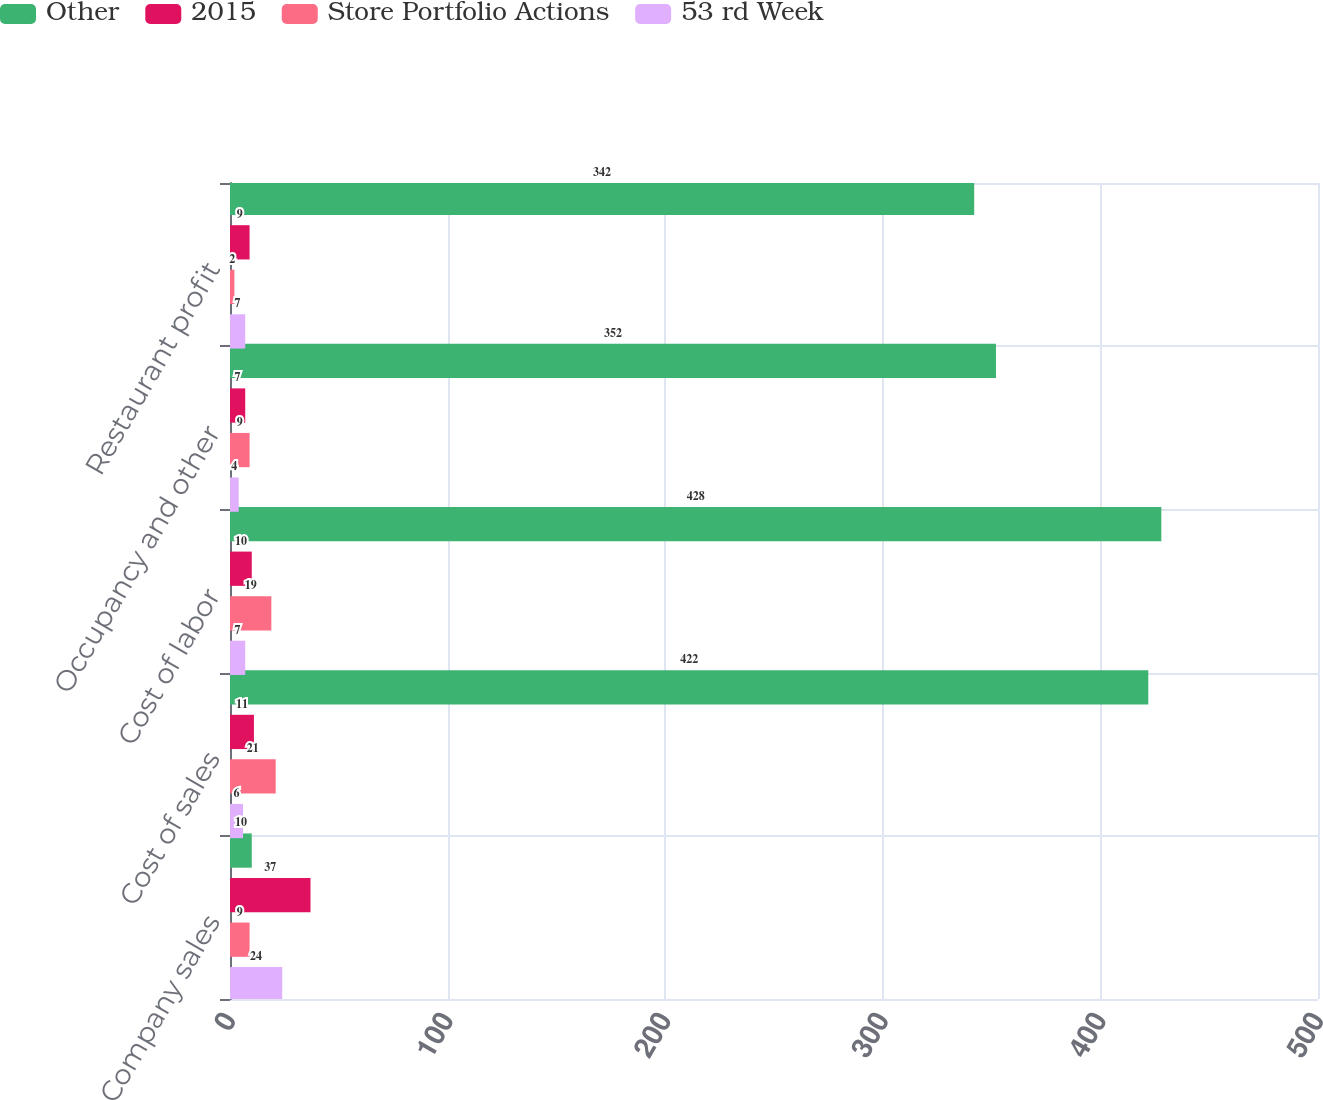<chart> <loc_0><loc_0><loc_500><loc_500><stacked_bar_chart><ecel><fcel>Company sales<fcel>Cost of sales<fcel>Cost of labor<fcel>Occupancy and other<fcel>Restaurant profit<nl><fcel>Other<fcel>10<fcel>422<fcel>428<fcel>352<fcel>342<nl><fcel>2015<fcel>37<fcel>11<fcel>10<fcel>7<fcel>9<nl><fcel>Store Portfolio Actions<fcel>9<fcel>21<fcel>19<fcel>9<fcel>2<nl><fcel>53 rd Week<fcel>24<fcel>6<fcel>7<fcel>4<fcel>7<nl></chart> 